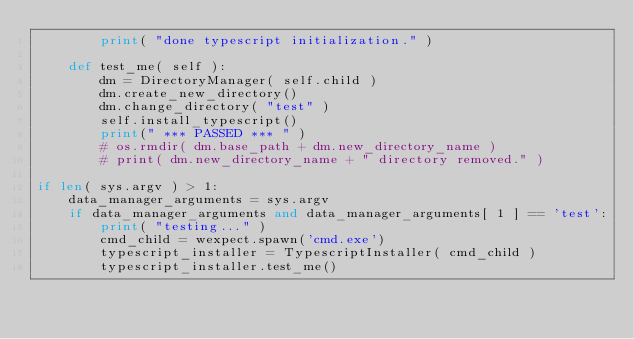Convert code to text. <code><loc_0><loc_0><loc_500><loc_500><_Python_>        print( "done typescript initialization." )

    def test_me( self ):
        dm = DirectoryManager( self.child ) 
        dm.create_new_directory()
        dm.change_directory( "test" )
        self.install_typescript()
        print(" *** PASSED *** " )
        # os.rmdir( dm.base_path + dm.new_directory_name )
        # print( dm.new_directory_name + " directory removed." )

if len( sys.argv ) > 1:
    data_manager_arguments = sys.argv
    if data_manager_arguments and data_manager_arguments[ 1 ] == 'test':
        print( "testing..." )
        cmd_child = wexpect.spawn('cmd.exe')
        typescript_installer = TypescriptInstaller( cmd_child )
        typescript_installer.test_me()    </code> 